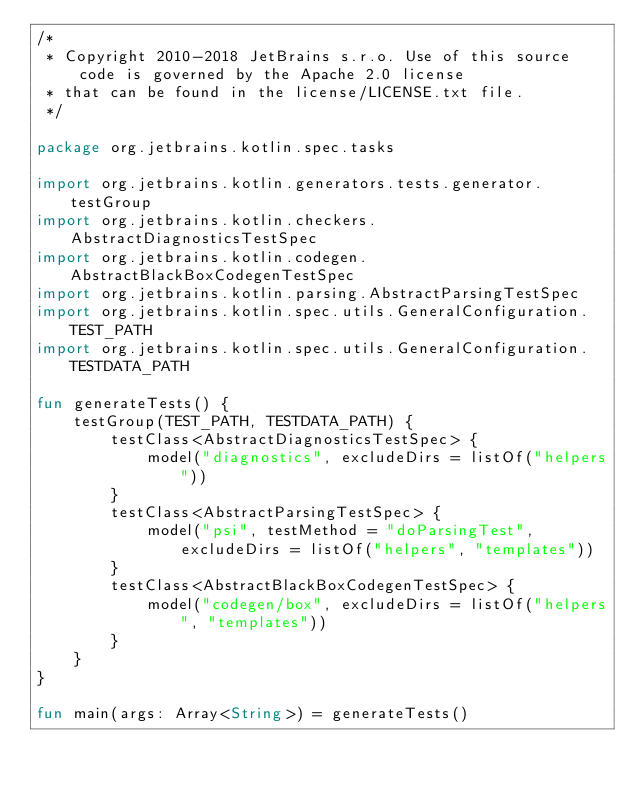Convert code to text. <code><loc_0><loc_0><loc_500><loc_500><_Kotlin_>/*
 * Copyright 2010-2018 JetBrains s.r.o. Use of this source code is governed by the Apache 2.0 license
 * that can be found in the license/LICENSE.txt file.
 */

package org.jetbrains.kotlin.spec.tasks

import org.jetbrains.kotlin.generators.tests.generator.testGroup
import org.jetbrains.kotlin.checkers.AbstractDiagnosticsTestSpec
import org.jetbrains.kotlin.codegen.AbstractBlackBoxCodegenTestSpec
import org.jetbrains.kotlin.parsing.AbstractParsingTestSpec
import org.jetbrains.kotlin.spec.utils.GeneralConfiguration.TEST_PATH
import org.jetbrains.kotlin.spec.utils.GeneralConfiguration.TESTDATA_PATH

fun generateTests() {
    testGroup(TEST_PATH, TESTDATA_PATH) {
        testClass<AbstractDiagnosticsTestSpec> {
            model("diagnostics", excludeDirs = listOf("helpers"))
        }
        testClass<AbstractParsingTestSpec> {
            model("psi", testMethod = "doParsingTest", excludeDirs = listOf("helpers", "templates"))
        }
        testClass<AbstractBlackBoxCodegenTestSpec> {
            model("codegen/box", excludeDirs = listOf("helpers", "templates"))
        }
    }
}

fun main(args: Array<String>) = generateTests()
</code> 